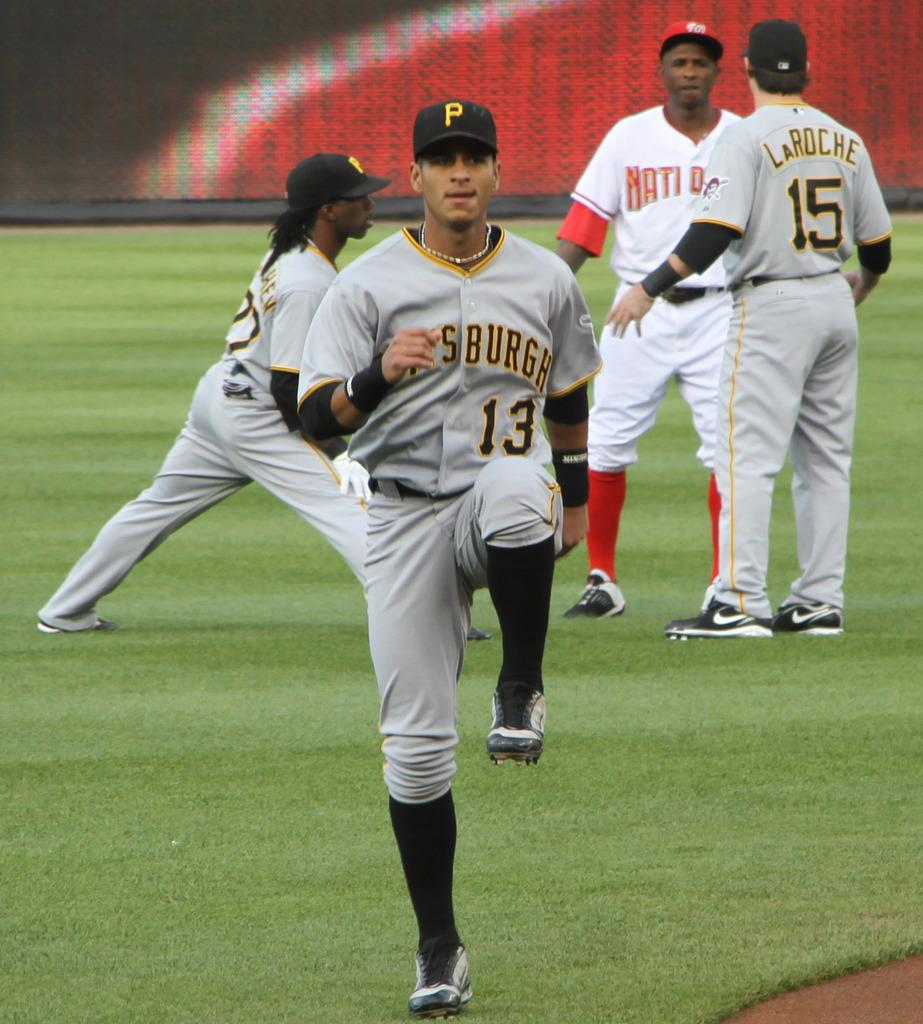<image>
Write a terse but informative summary of the picture. Some people play sports, one of whom has a number 13 on their chest 